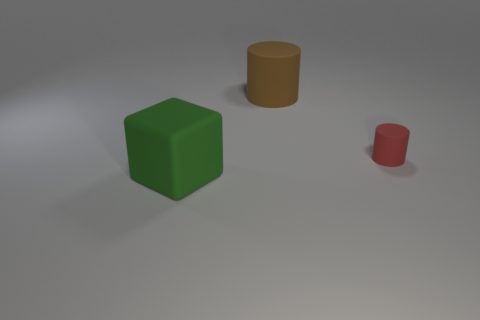What could these objects represent if they were part of a larger scene or story? If these objects were part of a larger scene or story, the green cube could represent a building or a piece of abstract art. The mustard yellow cylinder might be a barrel or a pillar, while the smaller crimson cylinder could symbolize something like a container or a character in an abstract setting. 